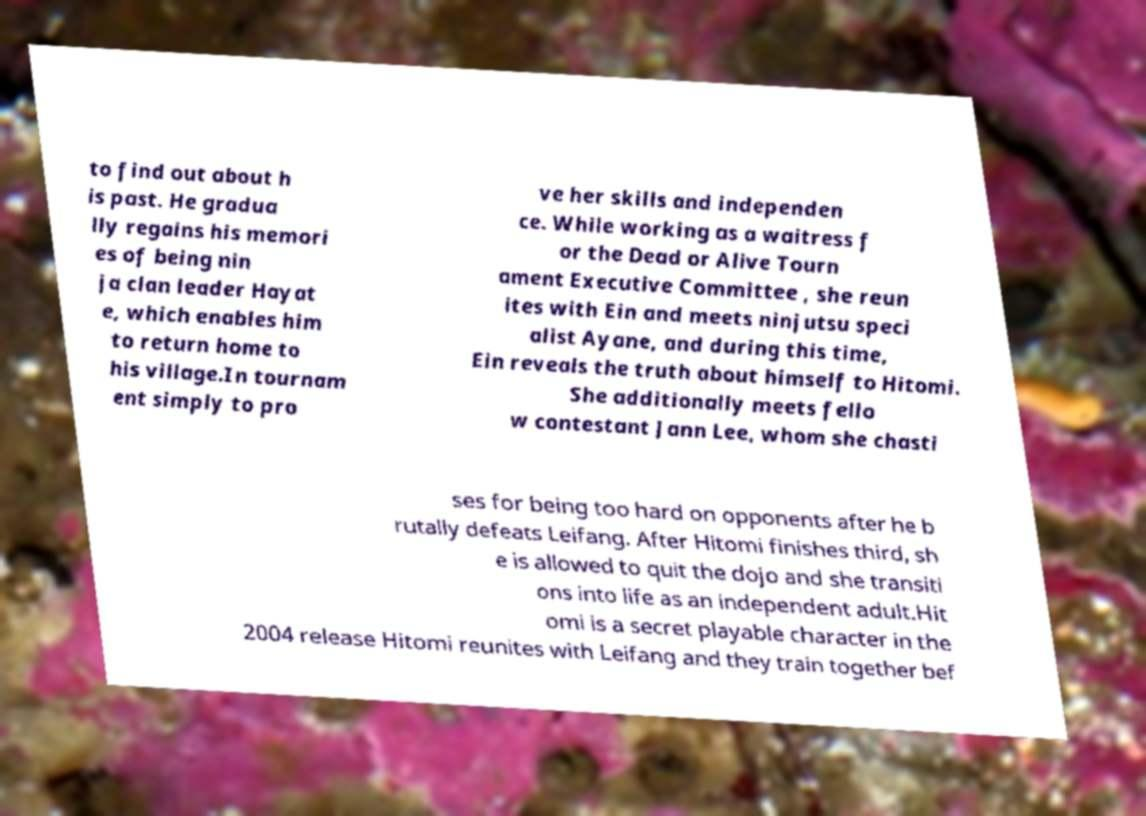For documentation purposes, I need the text within this image transcribed. Could you provide that? to find out about h is past. He gradua lly regains his memori es of being nin ja clan leader Hayat e, which enables him to return home to his village.In tournam ent simply to pro ve her skills and independen ce. While working as a waitress f or the Dead or Alive Tourn ament Executive Committee , she reun ites with Ein and meets ninjutsu speci alist Ayane, and during this time, Ein reveals the truth about himself to Hitomi. She additionally meets fello w contestant Jann Lee, whom she chasti ses for being too hard on opponents after he b rutally defeats Leifang. After Hitomi finishes third, sh e is allowed to quit the dojo and she transiti ons into life as an independent adult.Hit omi is a secret playable character in the 2004 release Hitomi reunites with Leifang and they train together bef 